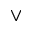Convert formula to latex. <formula><loc_0><loc_0><loc_500><loc_500>\vee</formula> 